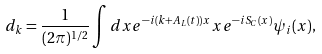<formula> <loc_0><loc_0><loc_500><loc_500>d _ { k } & = \frac { 1 } { ( 2 \pi ) ^ { 1 / 2 } } \int d x e ^ { - i ( k + A _ { L } ( t ) ) x } x e ^ { - i S _ { C } ( x ) } \psi _ { i } ( x ) ,</formula> 